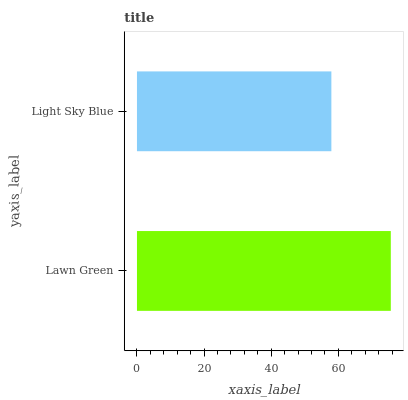Is Light Sky Blue the minimum?
Answer yes or no. Yes. Is Lawn Green the maximum?
Answer yes or no. Yes. Is Light Sky Blue the maximum?
Answer yes or no. No. Is Lawn Green greater than Light Sky Blue?
Answer yes or no. Yes. Is Light Sky Blue less than Lawn Green?
Answer yes or no. Yes. Is Light Sky Blue greater than Lawn Green?
Answer yes or no. No. Is Lawn Green less than Light Sky Blue?
Answer yes or no. No. Is Lawn Green the high median?
Answer yes or no. Yes. Is Light Sky Blue the low median?
Answer yes or no. Yes. Is Light Sky Blue the high median?
Answer yes or no. No. Is Lawn Green the low median?
Answer yes or no. No. 